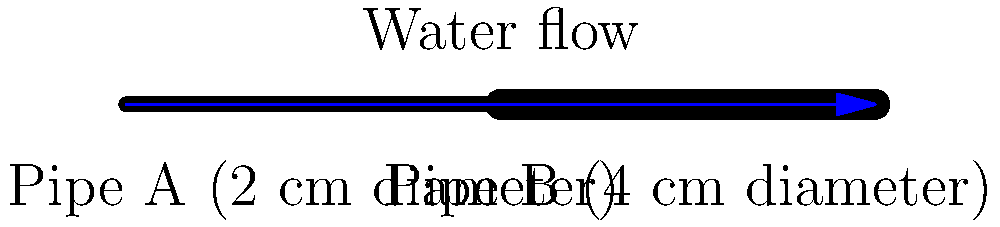In a simple plumbing system, water flows through two connected pipes of different sizes. Pipe A has a diameter of 2 cm, while Pipe B has a diameter of 4 cm. If the water velocity in Pipe A is 3 meters per second, what is the water velocity in Pipe B? Explain your reasoning in a way that could be understood by young viewers of an educational TV show. Let's break this down step-by-step for our young viewers:

1. First, we need to understand that the amount of water flowing through both pipes is the same. This is called the "continuity principle."

2. The amount of water flowing (Q) is calculated by multiplying the pipe's cross-sectional area (A) by the water's velocity (v):
   $Q = A \times v$

3. For Pipe A:
   - Diameter = 2 cm
   - Radius = 1 cm = 0.01 m
   - Area = $\pi r^2 = \pi \times (0.01)^2 = 0.000314$ m²
   - Velocity = 3 m/s
   - Flow rate = $0.000314 \times 3 = 0.000942$ m³/s

4. For Pipe B:
   - Diameter = 4 cm
   - Radius = 2 cm = 0.02 m
   - Area = $\pi r^2 = \pi \times (0.02)^2 = 0.001256$ m²
   - Velocity = unknown (let's call it v)

5. Since the flow rate is the same in both pipes:
   $0.000942 = 0.001256 \times v$

6. Solving for v:
   $v = 0.000942 \div 0.001256 = 0.75$ m/s

So, the water moves slower in the wider pipe, just like how a river flows slower when it gets wider!
Answer: 0.75 m/s 